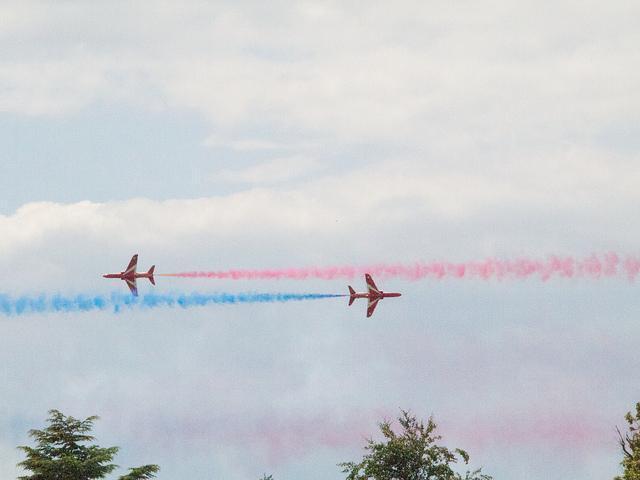How many vases in the picture?
Give a very brief answer. 0. 